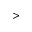<formula> <loc_0><loc_0><loc_500><loc_500>></formula> 